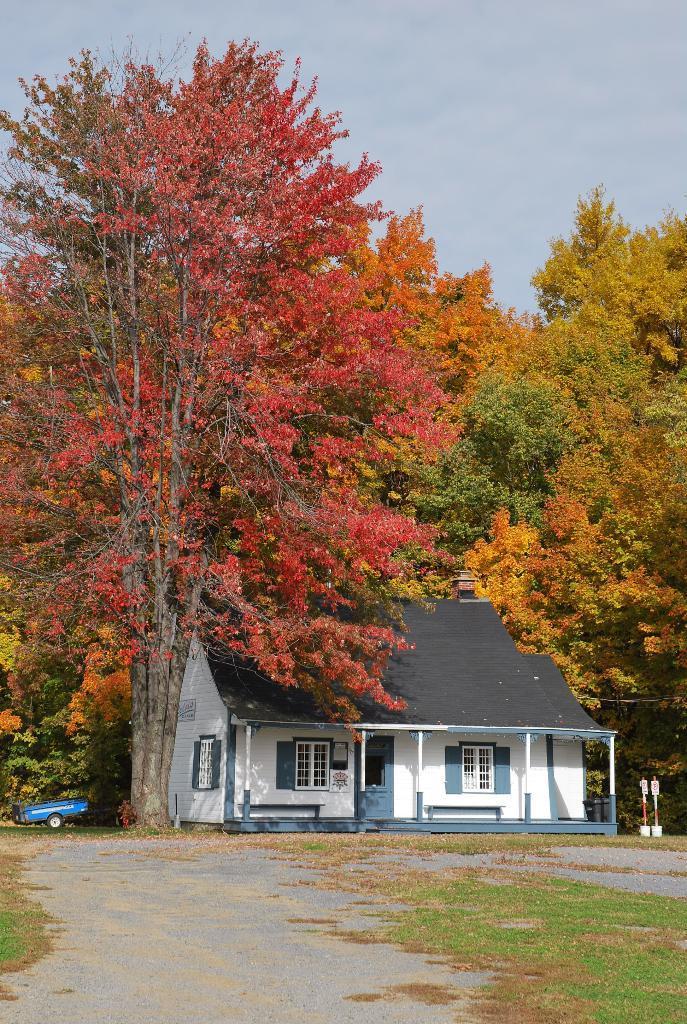How would you summarize this image in a sentence or two? In the center of the image there is a house. On the right and left side of the image we can see trees. At the bottom of the image we can see vehicle, road and grass. In the background there are clouds and sky. 